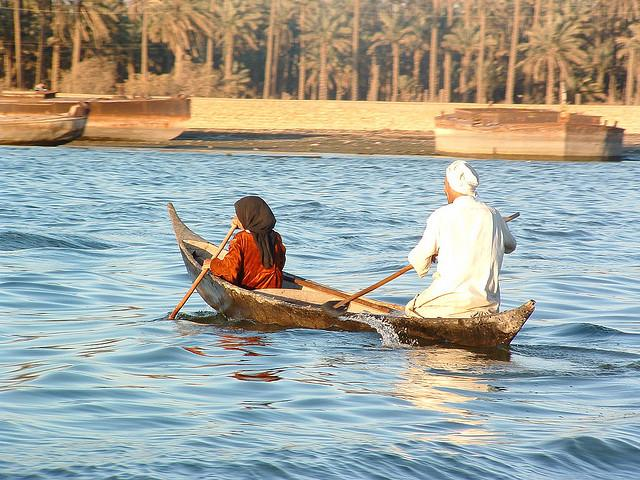What do the people have in their hands?

Choices:
A) eggs
B) paddles
C) swords
D) spears paddles 